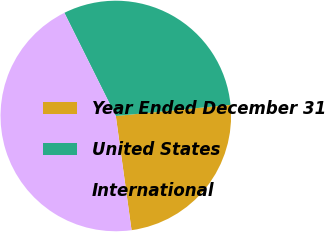Convert chart to OTSL. <chart><loc_0><loc_0><loc_500><loc_500><pie_chart><fcel>Year Ended December 31<fcel>United States<fcel>International<nl><fcel>24.36%<fcel>30.82%<fcel>44.82%<nl></chart> 